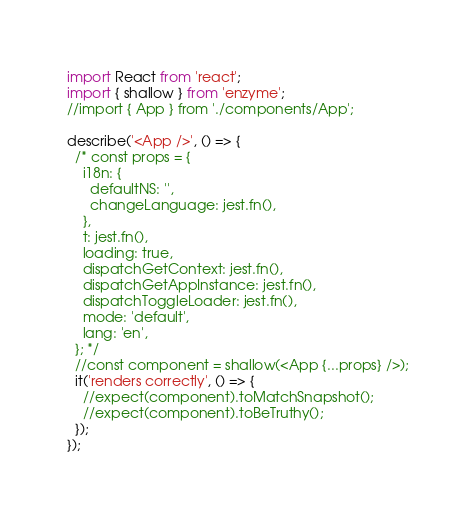Convert code to text. <code><loc_0><loc_0><loc_500><loc_500><_JavaScript_>import React from 'react';
import { shallow } from 'enzyme';
//import { App } from './components/App';

describe('<App />', () => {
  /* const props = {
    i18n: {
      defaultNS: '',
      changeLanguage: jest.fn(),
    },
    t: jest.fn(),
    loading: true,
    dispatchGetContext: jest.fn(),
    dispatchGetAppInstance: jest.fn(),
    dispatchToggleLoader: jest.fn(),
    mode: 'default',
    lang: 'en',
  }; */
  //const component = shallow(<App {...props} />);
  it('renders correctly', () => {
    //expect(component).toMatchSnapshot();
    //expect(component).toBeTruthy();
  });
});
</code> 